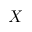Convert formula to latex. <formula><loc_0><loc_0><loc_500><loc_500>X</formula> 